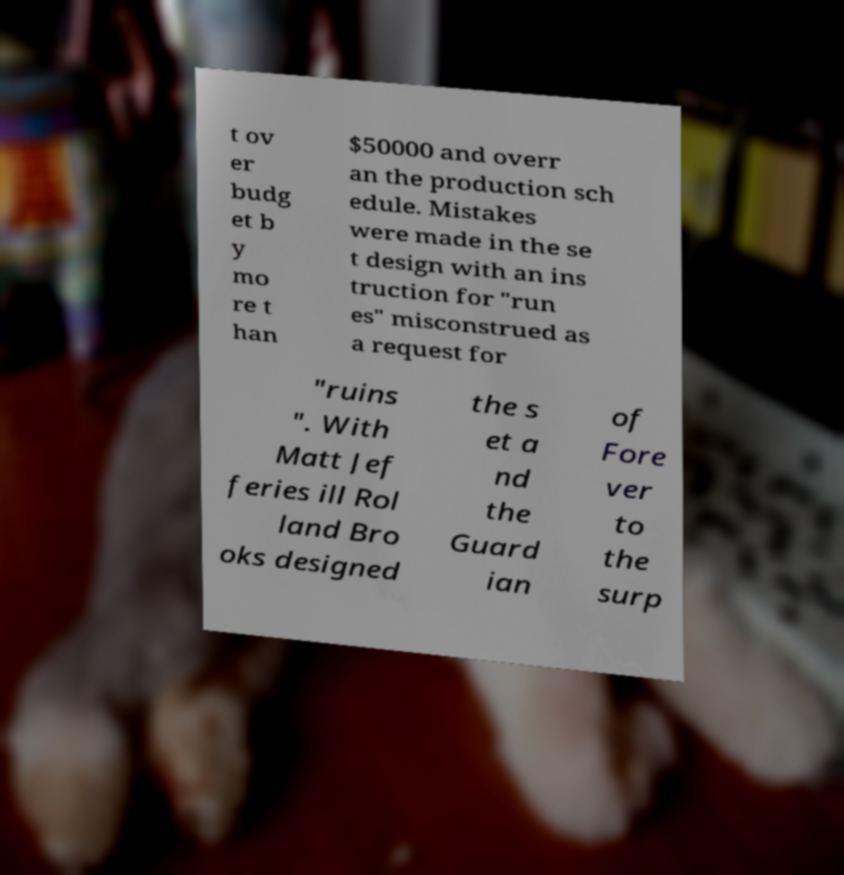I need the written content from this picture converted into text. Can you do that? t ov er budg et b y mo re t han $50000 and overr an the production sch edule. Mistakes were made in the se t design with an ins truction for "run es" misconstrued as a request for "ruins ". With Matt Jef feries ill Rol land Bro oks designed the s et a nd the Guard ian of Fore ver to the surp 